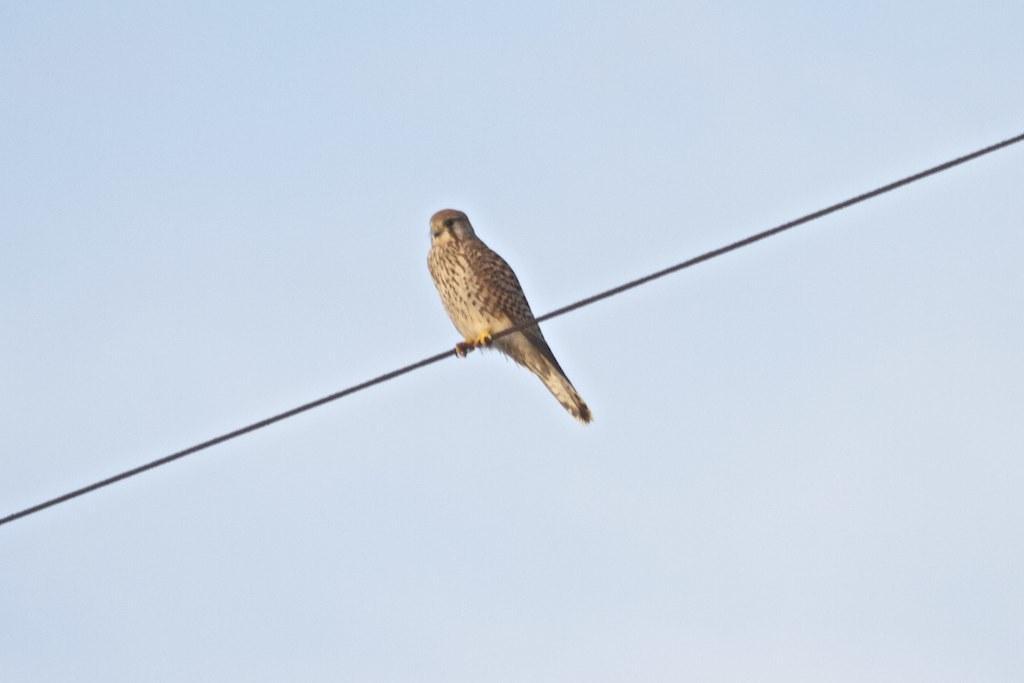Can you describe this image briefly? In this image, we can see a bird standing on the wire which is on the blue background. 